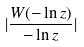<formula> <loc_0><loc_0><loc_500><loc_500>| \frac { W ( - \ln z ) } { - \ln z } |</formula> 